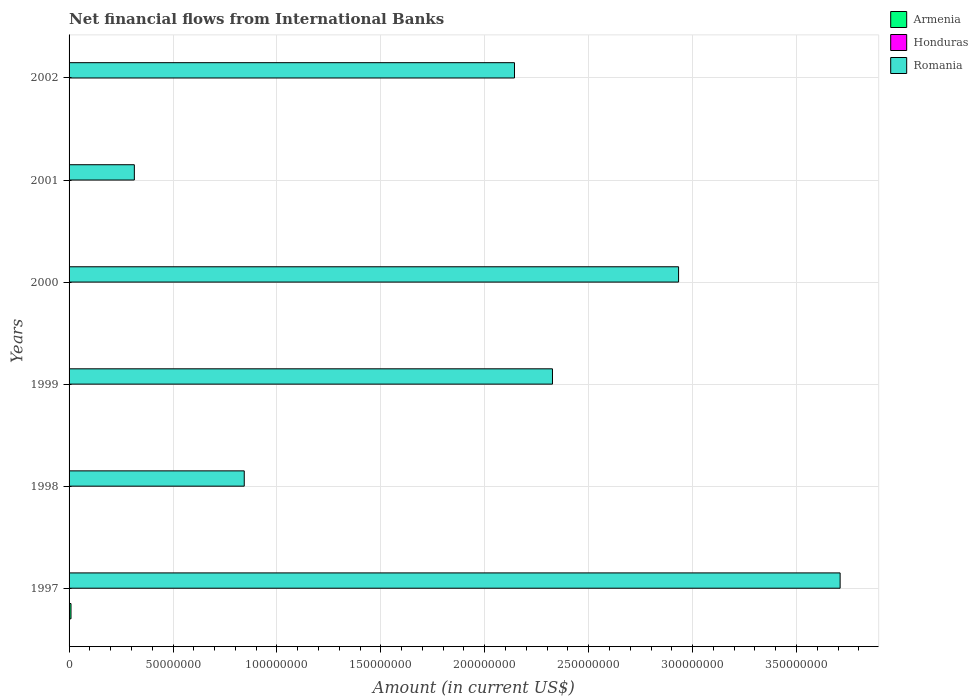Are the number of bars per tick equal to the number of legend labels?
Offer a terse response. No. How many bars are there on the 5th tick from the bottom?
Your answer should be very brief. 1. In how many cases, is the number of bars for a given year not equal to the number of legend labels?
Your answer should be compact. 6. What is the net financial aid flows in Romania in 2001?
Provide a succinct answer. 3.14e+07. Across all years, what is the maximum net financial aid flows in Armenia?
Your answer should be compact. 9.28e+05. Across all years, what is the minimum net financial aid flows in Romania?
Offer a terse response. 3.14e+07. In which year was the net financial aid flows in Romania maximum?
Your answer should be compact. 1997. What is the total net financial aid flows in Armenia in the graph?
Offer a very short reply. 9.28e+05. What is the difference between the net financial aid flows in Romania in 1999 and that in 2001?
Ensure brevity in your answer.  2.01e+08. In how many years, is the net financial aid flows in Armenia greater than 240000000 US$?
Keep it short and to the point. 0. What is the ratio of the net financial aid flows in Romania in 1997 to that in 2000?
Provide a succinct answer. 1.27. Is the net financial aid flows in Romania in 1997 less than that in 2001?
Provide a succinct answer. No. What is the difference between the highest and the second highest net financial aid flows in Romania?
Provide a short and direct response. 7.77e+07. What is the difference between the highest and the lowest net financial aid flows in Armenia?
Provide a succinct answer. 9.28e+05. Is the sum of the net financial aid flows in Romania in 1997 and 2002 greater than the maximum net financial aid flows in Armenia across all years?
Offer a very short reply. Yes. Is it the case that in every year, the sum of the net financial aid flows in Armenia and net financial aid flows in Honduras is greater than the net financial aid flows in Romania?
Make the answer very short. No. How many bars are there?
Ensure brevity in your answer.  7. How many years are there in the graph?
Keep it short and to the point. 6. What is the difference between two consecutive major ticks on the X-axis?
Your answer should be compact. 5.00e+07. Are the values on the major ticks of X-axis written in scientific E-notation?
Keep it short and to the point. No. Does the graph contain grids?
Provide a short and direct response. Yes. Where does the legend appear in the graph?
Your response must be concise. Top right. How many legend labels are there?
Your response must be concise. 3. How are the legend labels stacked?
Your response must be concise. Vertical. What is the title of the graph?
Your response must be concise. Net financial flows from International Banks. What is the Amount (in current US$) in Armenia in 1997?
Offer a very short reply. 9.28e+05. What is the Amount (in current US$) in Romania in 1997?
Make the answer very short. 3.71e+08. What is the Amount (in current US$) of Armenia in 1998?
Ensure brevity in your answer.  0. What is the Amount (in current US$) of Honduras in 1998?
Provide a short and direct response. 0. What is the Amount (in current US$) of Romania in 1998?
Provide a succinct answer. 8.43e+07. What is the Amount (in current US$) in Romania in 1999?
Make the answer very short. 2.33e+08. What is the Amount (in current US$) in Romania in 2000?
Your response must be concise. 2.93e+08. What is the Amount (in current US$) of Armenia in 2001?
Provide a succinct answer. 0. What is the Amount (in current US$) of Romania in 2001?
Your answer should be compact. 3.14e+07. What is the Amount (in current US$) in Romania in 2002?
Your answer should be very brief. 2.14e+08. Across all years, what is the maximum Amount (in current US$) of Armenia?
Provide a short and direct response. 9.28e+05. Across all years, what is the maximum Amount (in current US$) of Romania?
Give a very brief answer. 3.71e+08. Across all years, what is the minimum Amount (in current US$) of Romania?
Provide a succinct answer. 3.14e+07. What is the total Amount (in current US$) in Armenia in the graph?
Keep it short and to the point. 9.28e+05. What is the total Amount (in current US$) in Romania in the graph?
Keep it short and to the point. 1.23e+09. What is the difference between the Amount (in current US$) in Romania in 1997 and that in 1998?
Your answer should be compact. 2.87e+08. What is the difference between the Amount (in current US$) of Romania in 1997 and that in 1999?
Your answer should be very brief. 1.38e+08. What is the difference between the Amount (in current US$) of Romania in 1997 and that in 2000?
Your answer should be very brief. 7.77e+07. What is the difference between the Amount (in current US$) of Romania in 1997 and that in 2001?
Ensure brevity in your answer.  3.40e+08. What is the difference between the Amount (in current US$) in Romania in 1997 and that in 2002?
Give a very brief answer. 1.57e+08. What is the difference between the Amount (in current US$) in Romania in 1998 and that in 1999?
Your response must be concise. -1.48e+08. What is the difference between the Amount (in current US$) in Romania in 1998 and that in 2000?
Make the answer very short. -2.09e+08. What is the difference between the Amount (in current US$) of Romania in 1998 and that in 2001?
Ensure brevity in your answer.  5.29e+07. What is the difference between the Amount (in current US$) of Romania in 1998 and that in 2002?
Give a very brief answer. -1.30e+08. What is the difference between the Amount (in current US$) in Romania in 1999 and that in 2000?
Your answer should be compact. -6.07e+07. What is the difference between the Amount (in current US$) of Romania in 1999 and that in 2001?
Your answer should be compact. 2.01e+08. What is the difference between the Amount (in current US$) of Romania in 1999 and that in 2002?
Offer a very short reply. 1.83e+07. What is the difference between the Amount (in current US$) in Romania in 2000 and that in 2001?
Keep it short and to the point. 2.62e+08. What is the difference between the Amount (in current US$) of Romania in 2000 and that in 2002?
Provide a succinct answer. 7.89e+07. What is the difference between the Amount (in current US$) of Romania in 2001 and that in 2002?
Provide a short and direct response. -1.83e+08. What is the difference between the Amount (in current US$) of Armenia in 1997 and the Amount (in current US$) of Romania in 1998?
Provide a succinct answer. -8.34e+07. What is the difference between the Amount (in current US$) in Armenia in 1997 and the Amount (in current US$) in Romania in 1999?
Keep it short and to the point. -2.32e+08. What is the difference between the Amount (in current US$) in Armenia in 1997 and the Amount (in current US$) in Romania in 2000?
Your answer should be compact. -2.92e+08. What is the difference between the Amount (in current US$) of Armenia in 1997 and the Amount (in current US$) of Romania in 2001?
Your answer should be compact. -3.05e+07. What is the difference between the Amount (in current US$) in Armenia in 1997 and the Amount (in current US$) in Romania in 2002?
Keep it short and to the point. -2.13e+08. What is the average Amount (in current US$) of Armenia per year?
Offer a very short reply. 1.55e+05. What is the average Amount (in current US$) of Honduras per year?
Ensure brevity in your answer.  0. What is the average Amount (in current US$) in Romania per year?
Ensure brevity in your answer.  2.04e+08. In the year 1997, what is the difference between the Amount (in current US$) of Armenia and Amount (in current US$) of Romania?
Offer a terse response. -3.70e+08. What is the ratio of the Amount (in current US$) in Romania in 1997 to that in 1998?
Give a very brief answer. 4.4. What is the ratio of the Amount (in current US$) in Romania in 1997 to that in 1999?
Offer a very short reply. 1.6. What is the ratio of the Amount (in current US$) of Romania in 1997 to that in 2000?
Keep it short and to the point. 1.27. What is the ratio of the Amount (in current US$) in Romania in 1997 to that in 2001?
Your answer should be compact. 11.81. What is the ratio of the Amount (in current US$) of Romania in 1997 to that in 2002?
Give a very brief answer. 1.73. What is the ratio of the Amount (in current US$) in Romania in 1998 to that in 1999?
Your response must be concise. 0.36. What is the ratio of the Amount (in current US$) in Romania in 1998 to that in 2000?
Offer a terse response. 0.29. What is the ratio of the Amount (in current US$) of Romania in 1998 to that in 2001?
Offer a terse response. 2.68. What is the ratio of the Amount (in current US$) of Romania in 1998 to that in 2002?
Your answer should be very brief. 0.39. What is the ratio of the Amount (in current US$) of Romania in 1999 to that in 2000?
Give a very brief answer. 0.79. What is the ratio of the Amount (in current US$) of Romania in 1999 to that in 2001?
Offer a terse response. 7.41. What is the ratio of the Amount (in current US$) of Romania in 1999 to that in 2002?
Offer a terse response. 1.09. What is the ratio of the Amount (in current US$) of Romania in 2000 to that in 2001?
Ensure brevity in your answer.  9.34. What is the ratio of the Amount (in current US$) in Romania in 2000 to that in 2002?
Your answer should be compact. 1.37. What is the ratio of the Amount (in current US$) in Romania in 2001 to that in 2002?
Your response must be concise. 0.15. What is the difference between the highest and the second highest Amount (in current US$) in Romania?
Your response must be concise. 7.77e+07. What is the difference between the highest and the lowest Amount (in current US$) in Armenia?
Offer a very short reply. 9.28e+05. What is the difference between the highest and the lowest Amount (in current US$) in Romania?
Provide a short and direct response. 3.40e+08. 